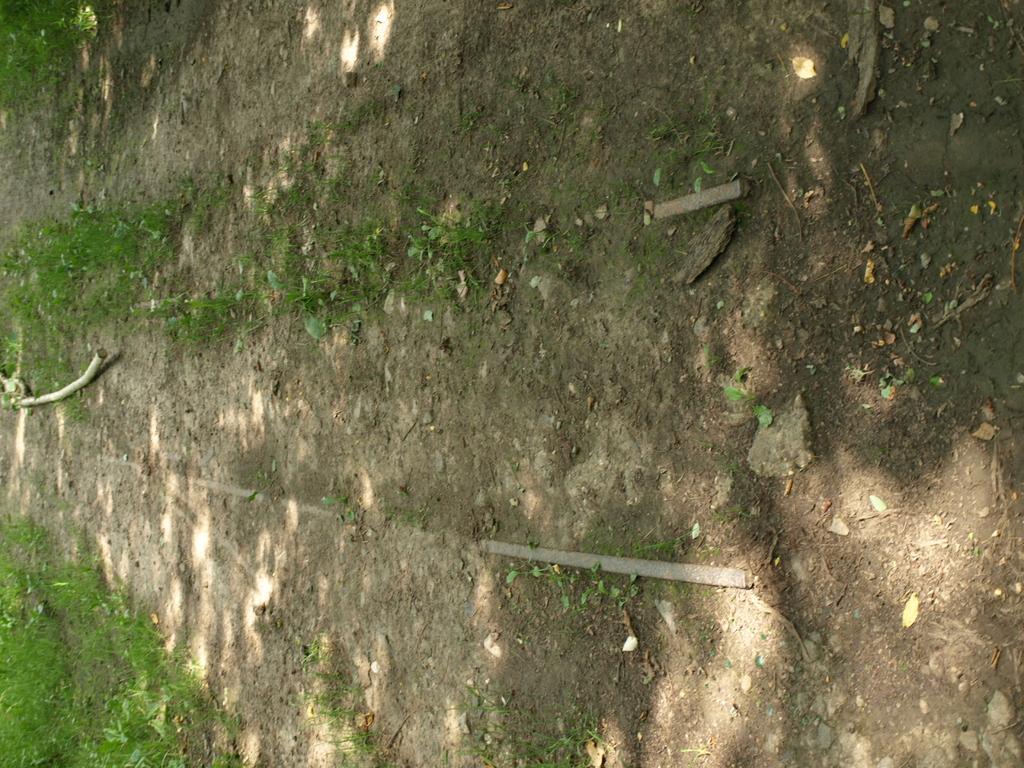How would you summarize this image in a sentence or two? In this image we can see a dirt ground. Left side of the image we can see a stick and grass.  